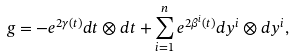<formula> <loc_0><loc_0><loc_500><loc_500>g = - e ^ { 2 { \gamma } ( t ) } d t \otimes d t + \sum _ { i = 1 } ^ { n } e ^ { 2 \beta ^ { i } ( t ) } d y ^ { i } \otimes d y ^ { i } ,</formula> 